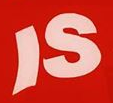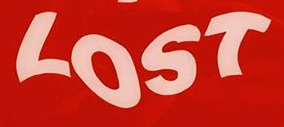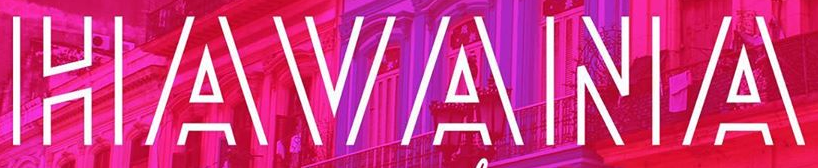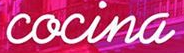Read the text from these images in sequence, separated by a semicolon. IS; LOST; HAVANA; cocina 